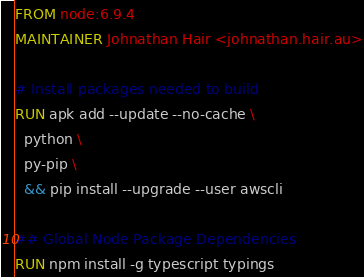<code> <loc_0><loc_0><loc_500><loc_500><_Dockerfile_>FROM node:6.9.4
MAINTAINER Johnathan Hair <johnathan.hair.au>

# Install packages needed to build
RUN apk add --update --no-cache \
  python \
  py-pip \
  && pip install --upgrade --user awscli

## Global Node Package Dependencies
RUN npm install -g typescript typings

</code> 